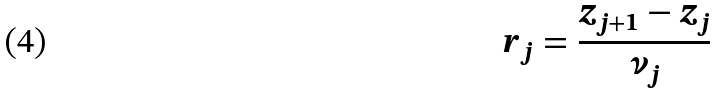<formula> <loc_0><loc_0><loc_500><loc_500>r _ { j } = \frac { z _ { j + 1 } - z _ { j } } { \nu _ { j } }</formula> 